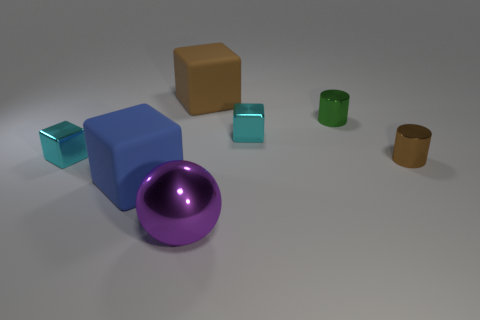Subtract all yellow cylinders. How many cyan cubes are left? 2 Subtract all blue rubber cubes. How many cubes are left? 3 Add 1 blue things. How many objects exist? 8 Subtract 1 cubes. How many cubes are left? 3 Subtract all blue cubes. How many cubes are left? 3 Subtract all blocks. How many objects are left? 3 Subtract all gray cubes. Subtract all cyan spheres. How many cubes are left? 4 Add 7 big red matte cylinders. How many big red matte cylinders exist? 7 Subtract 0 yellow spheres. How many objects are left? 7 Subtract all large purple things. Subtract all shiny things. How many objects are left? 1 